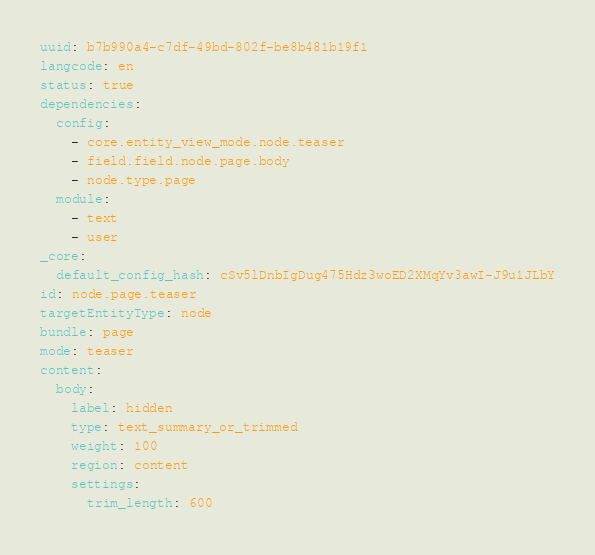Convert code to text. <code><loc_0><loc_0><loc_500><loc_500><_YAML_>uuid: b7b990a4-c7df-49bd-802f-be8b481b19f1
langcode: en
status: true
dependencies:
  config:
    - core.entity_view_mode.node.teaser
    - field.field.node.page.body
    - node.type.page
  module:
    - text
    - user
_core:
  default_config_hash: cSv5lDnbIgDug475Hdz3woED2XMqYv3awI-J9u1JLbY
id: node.page.teaser
targetEntityType: node
bundle: page
mode: teaser
content:
  body:
    label: hidden
    type: text_summary_or_trimmed
    weight: 100
    region: content
    settings:
      trim_length: 600</code> 